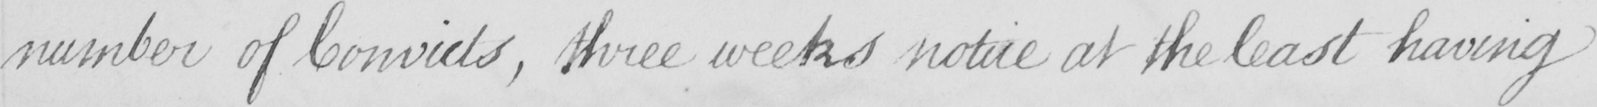Please transcribe the handwritten text in this image. number of Convicts , three weeks notice at the least having 